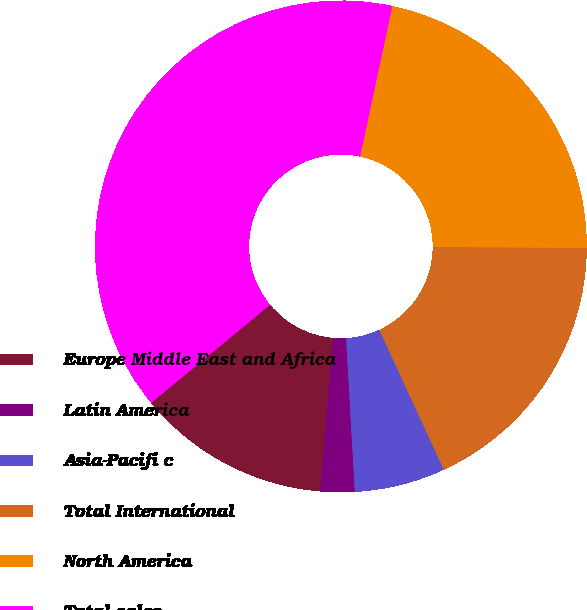Convert chart to OTSL. <chart><loc_0><loc_0><loc_500><loc_500><pie_chart><fcel>Europe Middle East and Africa<fcel>Latin America<fcel>Asia-Pacifi c<fcel>Total International<fcel>North America<fcel>Total sales<nl><fcel>12.67%<fcel>2.26%<fcel>5.97%<fcel>18.03%<fcel>21.74%<fcel>39.33%<nl></chart> 